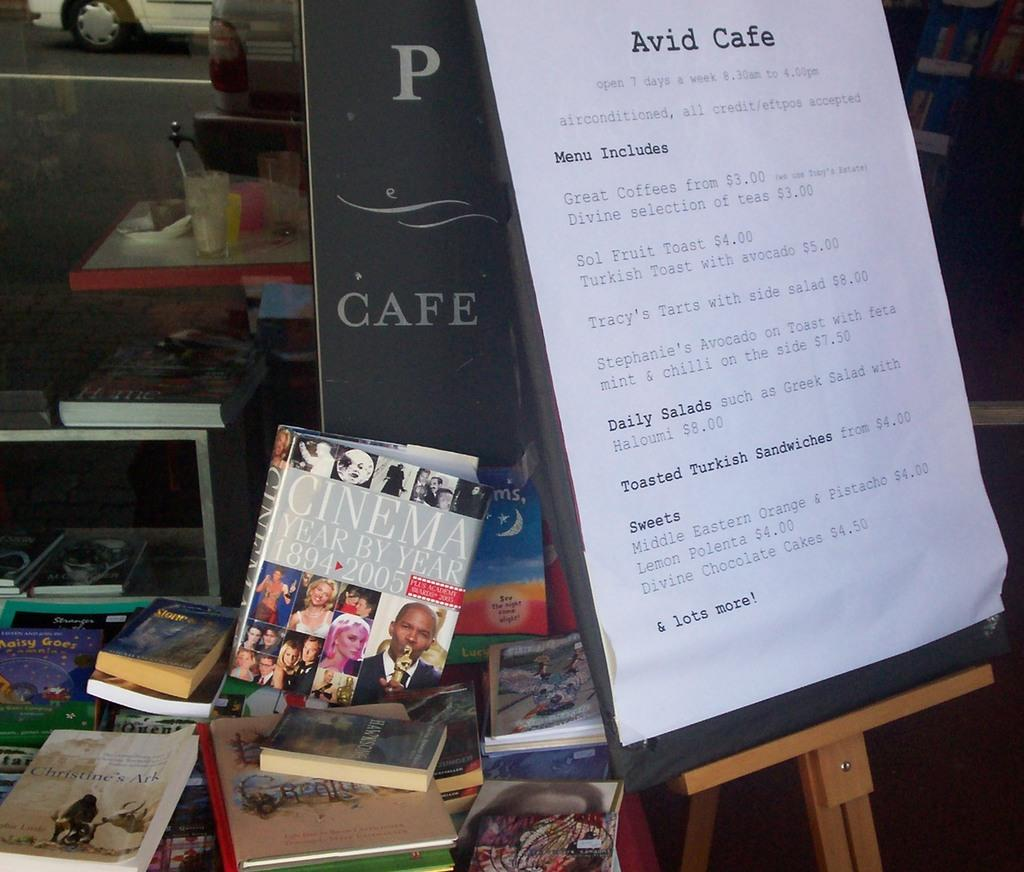<image>
Present a compact description of the photo's key features. a table with books on it outside the Avid Cafe. 